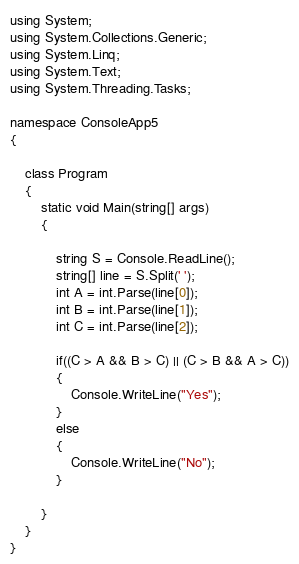<code> <loc_0><loc_0><loc_500><loc_500><_C#_>using System;
using System.Collections.Generic;
using System.Linq;
using System.Text;
using System.Threading.Tasks;

namespace ConsoleApp5
{

    class Program
    {
        static void Main(string[] args)
        {
            
            string S = Console.ReadLine();
            string[] line = S.Split(' ');
            int A = int.Parse(line[0]);
            int B = int.Parse(line[1]);
            int C = int.Parse(line[2]);

            if((C > A && B > C) || (C > B && A > C))
            {
                Console.WriteLine("Yes");
            }
            else
            {
                Console.WriteLine("No");
            }

        }
    }
}</code> 